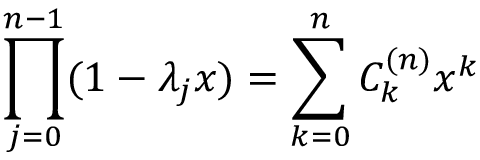<formula> <loc_0><loc_0><loc_500><loc_500>\prod _ { j = 0 } ^ { n - 1 } ( 1 - \lambda _ { j } x ) = \sum _ { k = 0 } ^ { n } C _ { k } ^ { ( n ) } x ^ { k }</formula> 